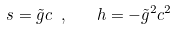Convert formula to latex. <formula><loc_0><loc_0><loc_500><loc_500>s = \tilde { g } c \ , \quad h = - \tilde { g } ^ { 2 } c ^ { 2 } \,</formula> 